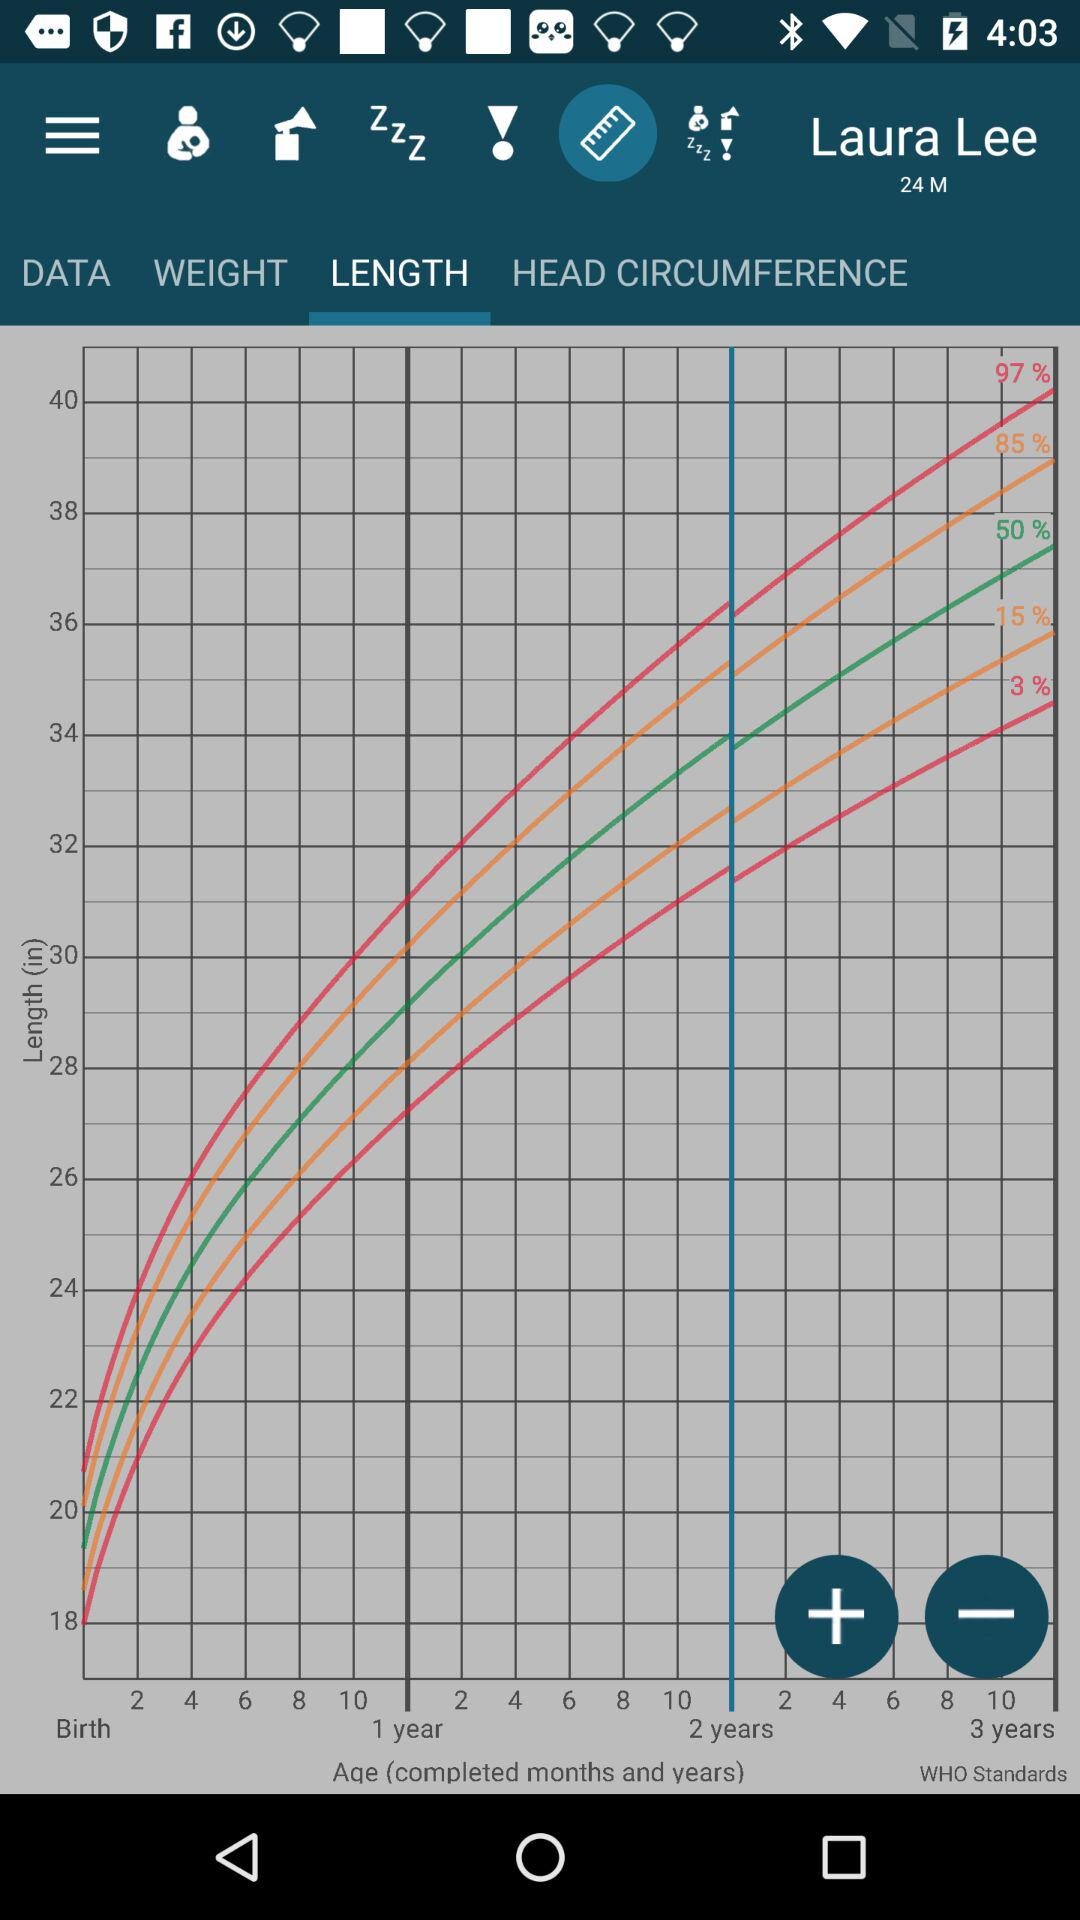How many months has Laura Lee been alive?
Answer the question using a single word or phrase. 24 